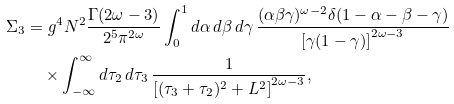Convert formula to latex. <formula><loc_0><loc_0><loc_500><loc_500>\Sigma _ { 3 } & = g ^ { 4 } N ^ { 2 } \frac { \Gamma ( 2 \omega - 3 ) } { 2 ^ { 5 } \pi ^ { 2 \omega } } \int _ { 0 } ^ { 1 } d \alpha \, d \beta \, d \gamma \, \frac { ( \alpha \beta \gamma ) ^ { \omega - 2 } \delta ( 1 - \alpha - \beta - \gamma ) } { \left [ \gamma ( 1 - \gamma ) \right ] ^ { 2 \omega - 3 } } \\ & \quad \times \int _ { - \infty } ^ { \infty } d \tau _ { 2 } \, d \tau _ { 3 } \, \frac { 1 } { \left [ ( \tau _ { 3 } + \tau _ { 2 } ) ^ { 2 } + L ^ { 2 } \right ] ^ { 2 \omega - 3 } } ,</formula> 